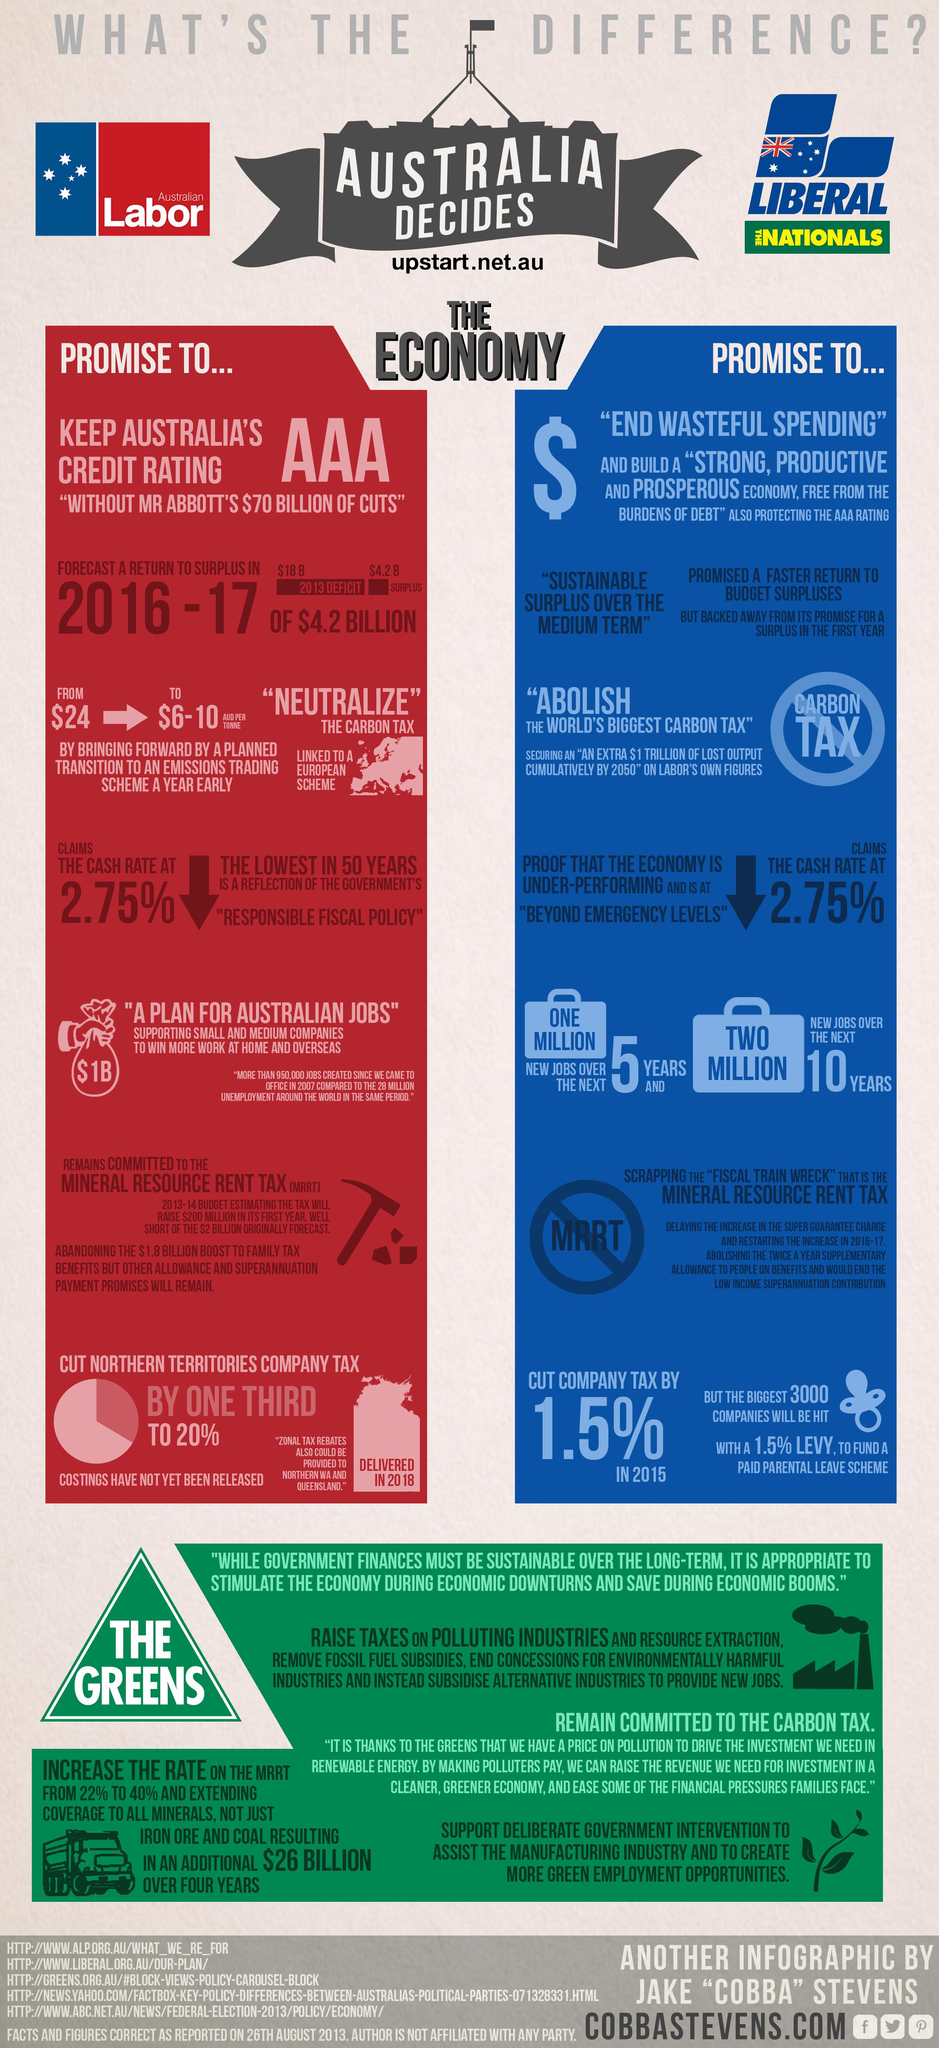List a handful of essential elements in this visual. The color blue represents the promises of the Liberal Nationals. The color red represents the promises of the Australian Labor Party. 